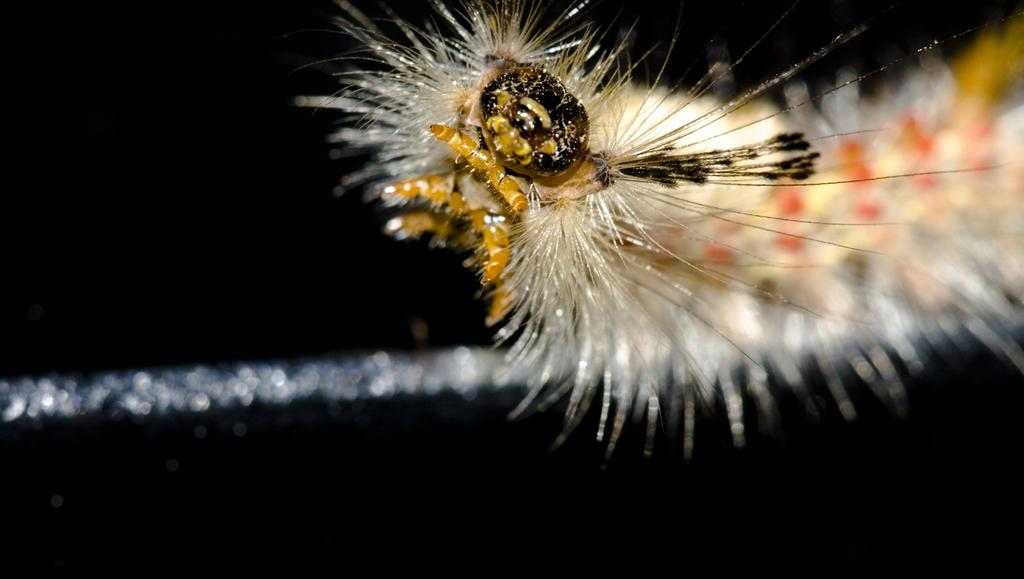What type of creature is in the image? There is an insect in the image. What colors can be seen on the insect? The insect has brown, black, and white colors. What is the color of the background in the image? The background of the image is dark. How many trucks can be seen in the image? There are no trucks present in the image; it features an insect with specific colors against a dark background. 